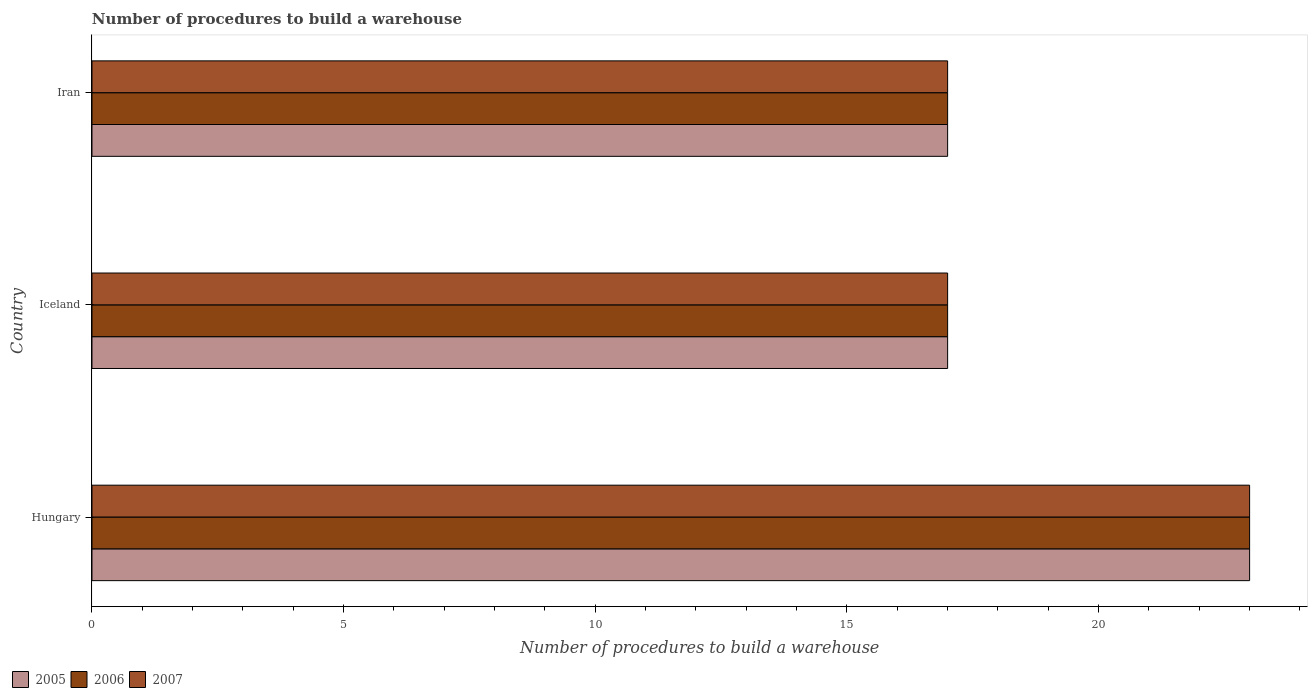How many bars are there on the 3rd tick from the bottom?
Make the answer very short. 3. What is the label of the 3rd group of bars from the top?
Your answer should be compact. Hungary. In how many cases, is the number of bars for a given country not equal to the number of legend labels?
Your answer should be very brief. 0. Across all countries, what is the maximum number of procedures to build a warehouse in in 2005?
Your answer should be compact. 23. In which country was the number of procedures to build a warehouse in in 2007 maximum?
Provide a succinct answer. Hungary. In which country was the number of procedures to build a warehouse in in 2007 minimum?
Keep it short and to the point. Iceland. What is the total number of procedures to build a warehouse in in 2007 in the graph?
Provide a short and direct response. 57. What is the difference between the number of procedures to build a warehouse in in 2005 in Hungary and that in Iran?
Keep it short and to the point. 6. In how many countries, is the number of procedures to build a warehouse in in 2005 greater than 17 ?
Give a very brief answer. 1. What is the ratio of the number of procedures to build a warehouse in in 2005 in Hungary to that in Iran?
Make the answer very short. 1.35. Is the number of procedures to build a warehouse in in 2007 in Iceland less than that in Iran?
Your answer should be compact. No. What is the difference between the highest and the second highest number of procedures to build a warehouse in in 2005?
Provide a succinct answer. 6. What is the difference between the highest and the lowest number of procedures to build a warehouse in in 2005?
Keep it short and to the point. 6. In how many countries, is the number of procedures to build a warehouse in in 2005 greater than the average number of procedures to build a warehouse in in 2005 taken over all countries?
Make the answer very short. 1. Is the sum of the number of procedures to build a warehouse in in 2006 in Iceland and Iran greater than the maximum number of procedures to build a warehouse in in 2007 across all countries?
Provide a succinct answer. Yes. What does the 2nd bar from the top in Iceland represents?
Your answer should be very brief. 2006. Is it the case that in every country, the sum of the number of procedures to build a warehouse in in 2006 and number of procedures to build a warehouse in in 2007 is greater than the number of procedures to build a warehouse in in 2005?
Make the answer very short. Yes. How many bars are there?
Offer a terse response. 9. Does the graph contain any zero values?
Offer a terse response. No. Does the graph contain grids?
Your response must be concise. No. Where does the legend appear in the graph?
Ensure brevity in your answer.  Bottom left. How are the legend labels stacked?
Your response must be concise. Horizontal. What is the title of the graph?
Make the answer very short. Number of procedures to build a warehouse. What is the label or title of the X-axis?
Offer a terse response. Number of procedures to build a warehouse. What is the label or title of the Y-axis?
Provide a succinct answer. Country. What is the Number of procedures to build a warehouse in 2006 in Hungary?
Provide a short and direct response. 23. What is the Number of procedures to build a warehouse in 2007 in Hungary?
Make the answer very short. 23. What is the Number of procedures to build a warehouse in 2005 in Iceland?
Ensure brevity in your answer.  17. What is the Number of procedures to build a warehouse in 2006 in Iceland?
Give a very brief answer. 17. What is the Number of procedures to build a warehouse in 2007 in Iceland?
Offer a terse response. 17. What is the Number of procedures to build a warehouse of 2006 in Iran?
Offer a terse response. 17. What is the Number of procedures to build a warehouse of 2007 in Iran?
Offer a very short reply. 17. Across all countries, what is the maximum Number of procedures to build a warehouse of 2005?
Ensure brevity in your answer.  23. Across all countries, what is the maximum Number of procedures to build a warehouse of 2006?
Provide a short and direct response. 23. Across all countries, what is the maximum Number of procedures to build a warehouse of 2007?
Provide a succinct answer. 23. Across all countries, what is the minimum Number of procedures to build a warehouse in 2005?
Ensure brevity in your answer.  17. Across all countries, what is the minimum Number of procedures to build a warehouse in 2006?
Your answer should be compact. 17. Across all countries, what is the minimum Number of procedures to build a warehouse in 2007?
Make the answer very short. 17. What is the total Number of procedures to build a warehouse of 2006 in the graph?
Provide a short and direct response. 57. What is the difference between the Number of procedures to build a warehouse of 2007 in Hungary and that in Iceland?
Provide a succinct answer. 6. What is the difference between the Number of procedures to build a warehouse in 2005 in Hungary and that in Iran?
Provide a short and direct response. 6. What is the difference between the Number of procedures to build a warehouse of 2006 in Hungary and that in Iran?
Offer a very short reply. 6. What is the difference between the Number of procedures to build a warehouse of 2007 in Hungary and that in Iran?
Offer a terse response. 6. What is the difference between the Number of procedures to build a warehouse in 2005 in Iceland and that in Iran?
Make the answer very short. 0. What is the difference between the Number of procedures to build a warehouse of 2006 in Iceland and that in Iran?
Make the answer very short. 0. What is the difference between the Number of procedures to build a warehouse in 2007 in Iceland and that in Iran?
Keep it short and to the point. 0. What is the difference between the Number of procedures to build a warehouse of 2005 in Hungary and the Number of procedures to build a warehouse of 2007 in Iceland?
Your response must be concise. 6. What is the difference between the Number of procedures to build a warehouse of 2005 in Hungary and the Number of procedures to build a warehouse of 2007 in Iran?
Your answer should be compact. 6. What is the difference between the Number of procedures to build a warehouse in 2006 in Hungary and the Number of procedures to build a warehouse in 2007 in Iran?
Your response must be concise. 6. What is the difference between the Number of procedures to build a warehouse of 2005 in Iceland and the Number of procedures to build a warehouse of 2006 in Iran?
Provide a succinct answer. 0. What is the difference between the Number of procedures to build a warehouse in 2005 in Iceland and the Number of procedures to build a warehouse in 2007 in Iran?
Give a very brief answer. 0. What is the difference between the Number of procedures to build a warehouse of 2006 in Iceland and the Number of procedures to build a warehouse of 2007 in Iran?
Offer a terse response. 0. What is the average Number of procedures to build a warehouse in 2006 per country?
Provide a succinct answer. 19. What is the difference between the Number of procedures to build a warehouse of 2005 and Number of procedures to build a warehouse of 2006 in Iceland?
Make the answer very short. 0. What is the difference between the Number of procedures to build a warehouse of 2005 and Number of procedures to build a warehouse of 2007 in Iran?
Your answer should be very brief. 0. What is the ratio of the Number of procedures to build a warehouse of 2005 in Hungary to that in Iceland?
Your answer should be very brief. 1.35. What is the ratio of the Number of procedures to build a warehouse in 2006 in Hungary to that in Iceland?
Offer a very short reply. 1.35. What is the ratio of the Number of procedures to build a warehouse of 2007 in Hungary to that in Iceland?
Provide a short and direct response. 1.35. What is the ratio of the Number of procedures to build a warehouse in 2005 in Hungary to that in Iran?
Your answer should be very brief. 1.35. What is the ratio of the Number of procedures to build a warehouse in 2006 in Hungary to that in Iran?
Your answer should be compact. 1.35. What is the ratio of the Number of procedures to build a warehouse in 2007 in Hungary to that in Iran?
Give a very brief answer. 1.35. What is the difference between the highest and the second highest Number of procedures to build a warehouse in 2005?
Provide a succinct answer. 6. What is the difference between the highest and the second highest Number of procedures to build a warehouse of 2006?
Provide a short and direct response. 6. What is the difference between the highest and the second highest Number of procedures to build a warehouse of 2007?
Offer a terse response. 6. What is the difference between the highest and the lowest Number of procedures to build a warehouse in 2007?
Your answer should be very brief. 6. 